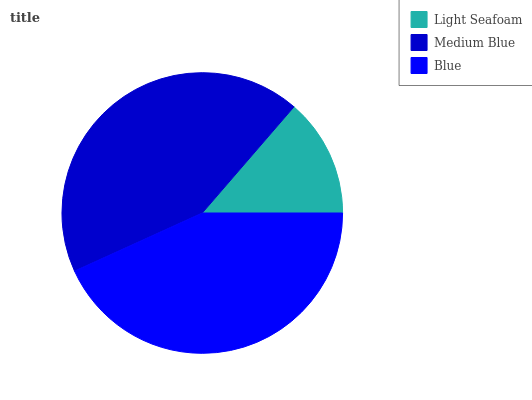Is Light Seafoam the minimum?
Answer yes or no. Yes. Is Blue the maximum?
Answer yes or no. Yes. Is Medium Blue the minimum?
Answer yes or no. No. Is Medium Blue the maximum?
Answer yes or no. No. Is Medium Blue greater than Light Seafoam?
Answer yes or no. Yes. Is Light Seafoam less than Medium Blue?
Answer yes or no. Yes. Is Light Seafoam greater than Medium Blue?
Answer yes or no. No. Is Medium Blue less than Light Seafoam?
Answer yes or no. No. Is Medium Blue the high median?
Answer yes or no. Yes. Is Medium Blue the low median?
Answer yes or no. Yes. Is Blue the high median?
Answer yes or no. No. Is Blue the low median?
Answer yes or no. No. 